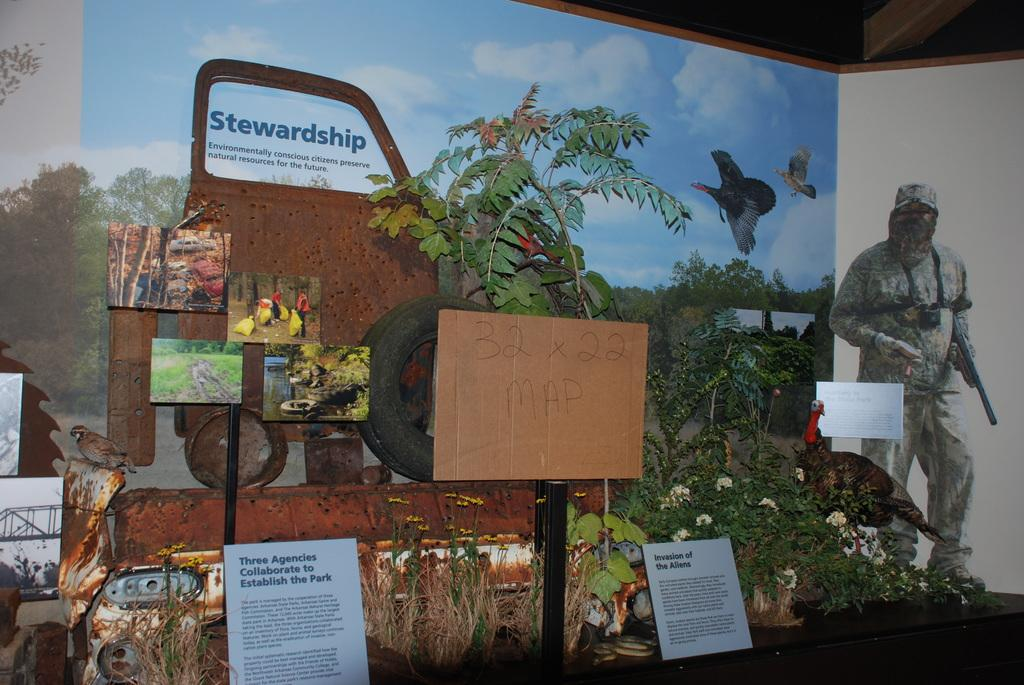What is located in the center of the image? There are banners with text in the center of the image. What type of objects can be seen in the image besides the banners? There are plants and frames visible in the image. Can you describe the bird in the image? There is a bird on the left side of the image. What color is the hammer in the image? There is no hammer present in the image. 